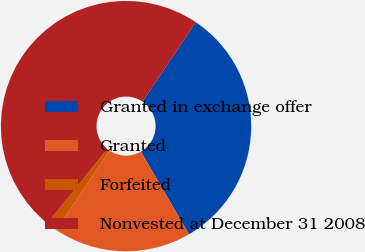<chart> <loc_0><loc_0><loc_500><loc_500><pie_chart><fcel>Granted in exchange offer<fcel>Granted<fcel>Forfeited<fcel>Nonvested at December 31 2008<nl><fcel>32.21%<fcel>17.79%<fcel>1.43%<fcel>48.57%<nl></chart> 